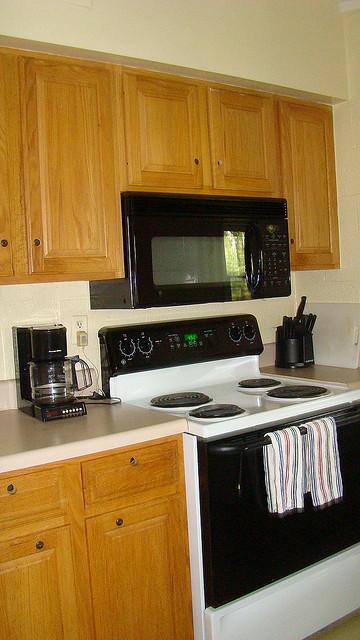Is this kitchen clean?
Answer briefly. Yes. What color is the towel hanging on the oven?
Answer briefly. Multi. Is there something cooking in the microwave?
Give a very brief answer. No. Is this an electric stove?
Be succinct. Yes. What color are the cabinets?
Give a very brief answer. Brown. 